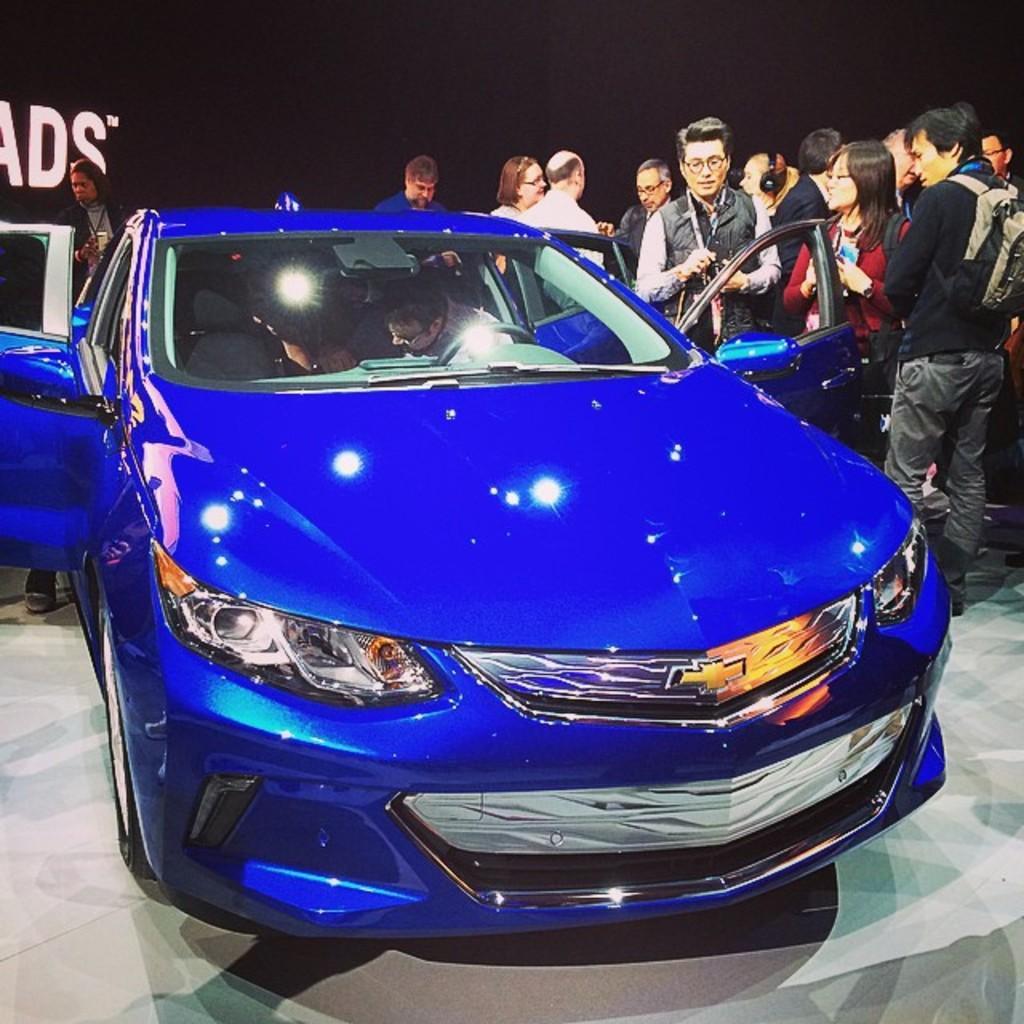Could you give a brief overview of what you see in this image? In the center of the image a car is there. In car a person is sitting. On the right side of the image a group of people are standing. In the background of the image a board is there. At the bottom of the image floor is there. 